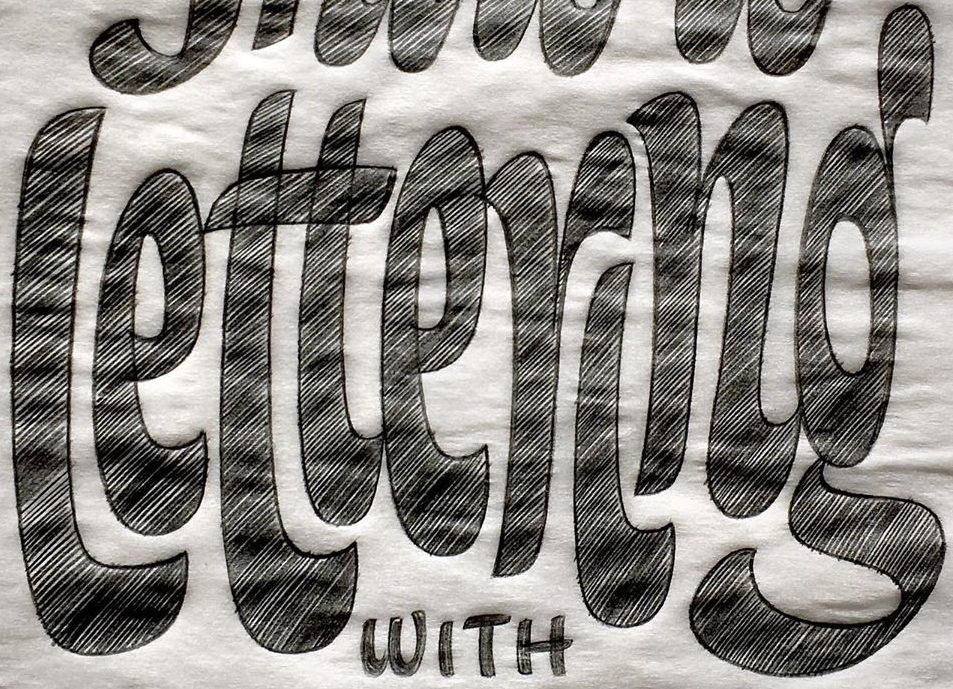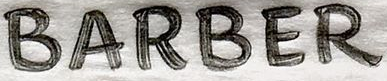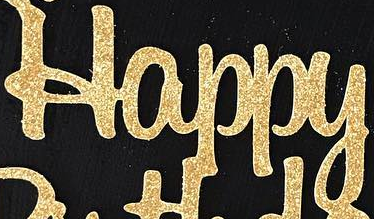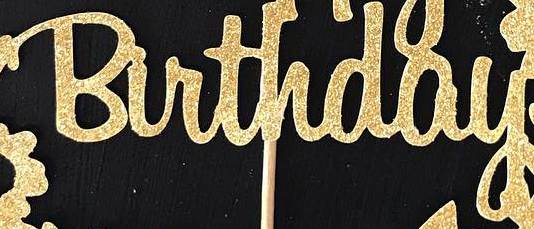What text is displayed in these images sequentially, separated by a semicolon? lettering; BARBER; Happy; Birthday 